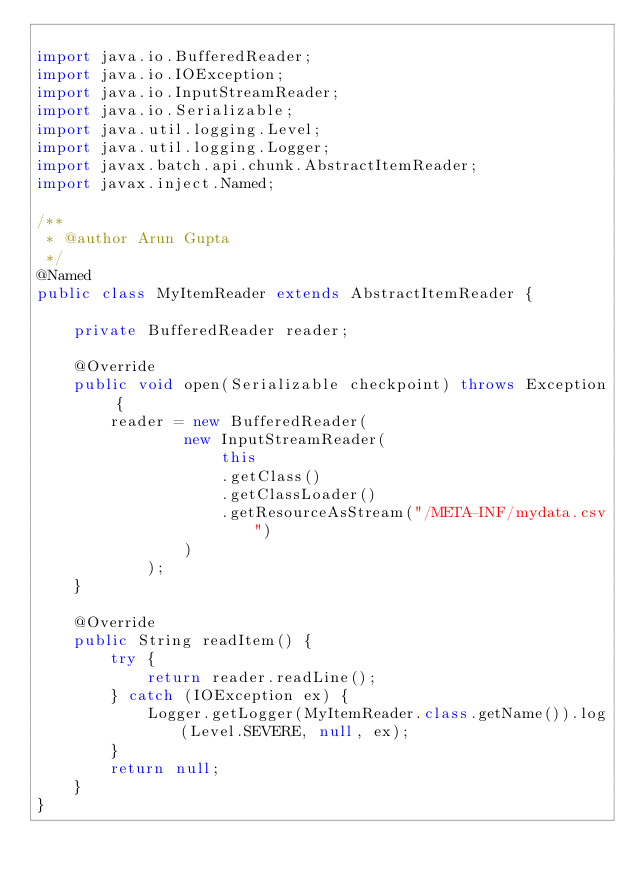Convert code to text. <code><loc_0><loc_0><loc_500><loc_500><_Java_>
import java.io.BufferedReader;
import java.io.IOException;
import java.io.InputStreamReader;
import java.io.Serializable;
import java.util.logging.Level;
import java.util.logging.Logger;
import javax.batch.api.chunk.AbstractItemReader;
import javax.inject.Named;

/**
 * @author Arun Gupta
 */
@Named
public class MyItemReader extends AbstractItemReader {

    private BufferedReader reader;

    @Override
    public void open(Serializable checkpoint) throws Exception {
        reader = new BufferedReader(
                new InputStreamReader(
                    this
                    .getClass()
                    .getClassLoader()
                    .getResourceAsStream("/META-INF/mydata.csv")
                )
            );
    }

    @Override
    public String readItem() {
        try {
            return reader.readLine();
        } catch (IOException ex) {
            Logger.getLogger(MyItemReader.class.getName()).log(Level.SEVERE, null, ex);
        }
        return null;
    }
}
</code> 